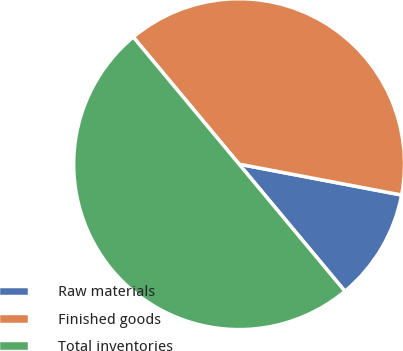Convert chart to OTSL. <chart><loc_0><loc_0><loc_500><loc_500><pie_chart><fcel>Raw materials<fcel>Finished goods<fcel>Total inventories<nl><fcel>10.96%<fcel>39.04%<fcel>50.0%<nl></chart> 